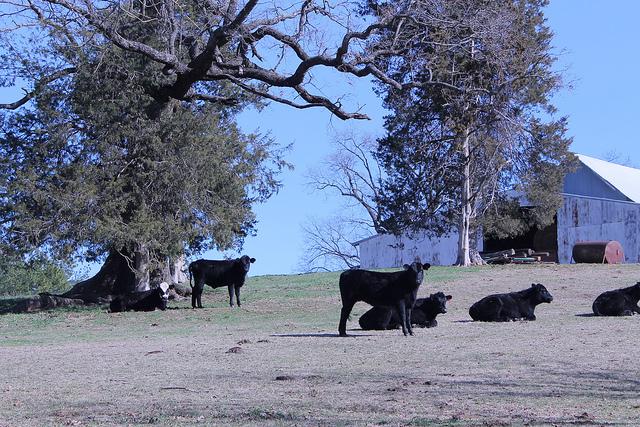How many cows are there?
Answer briefly. 6. What are the cows doing?
Keep it brief. Resting. How many cows are standing?
Short answer required. 2. Which cow has 2 colors?
Answer briefly. One on left. 